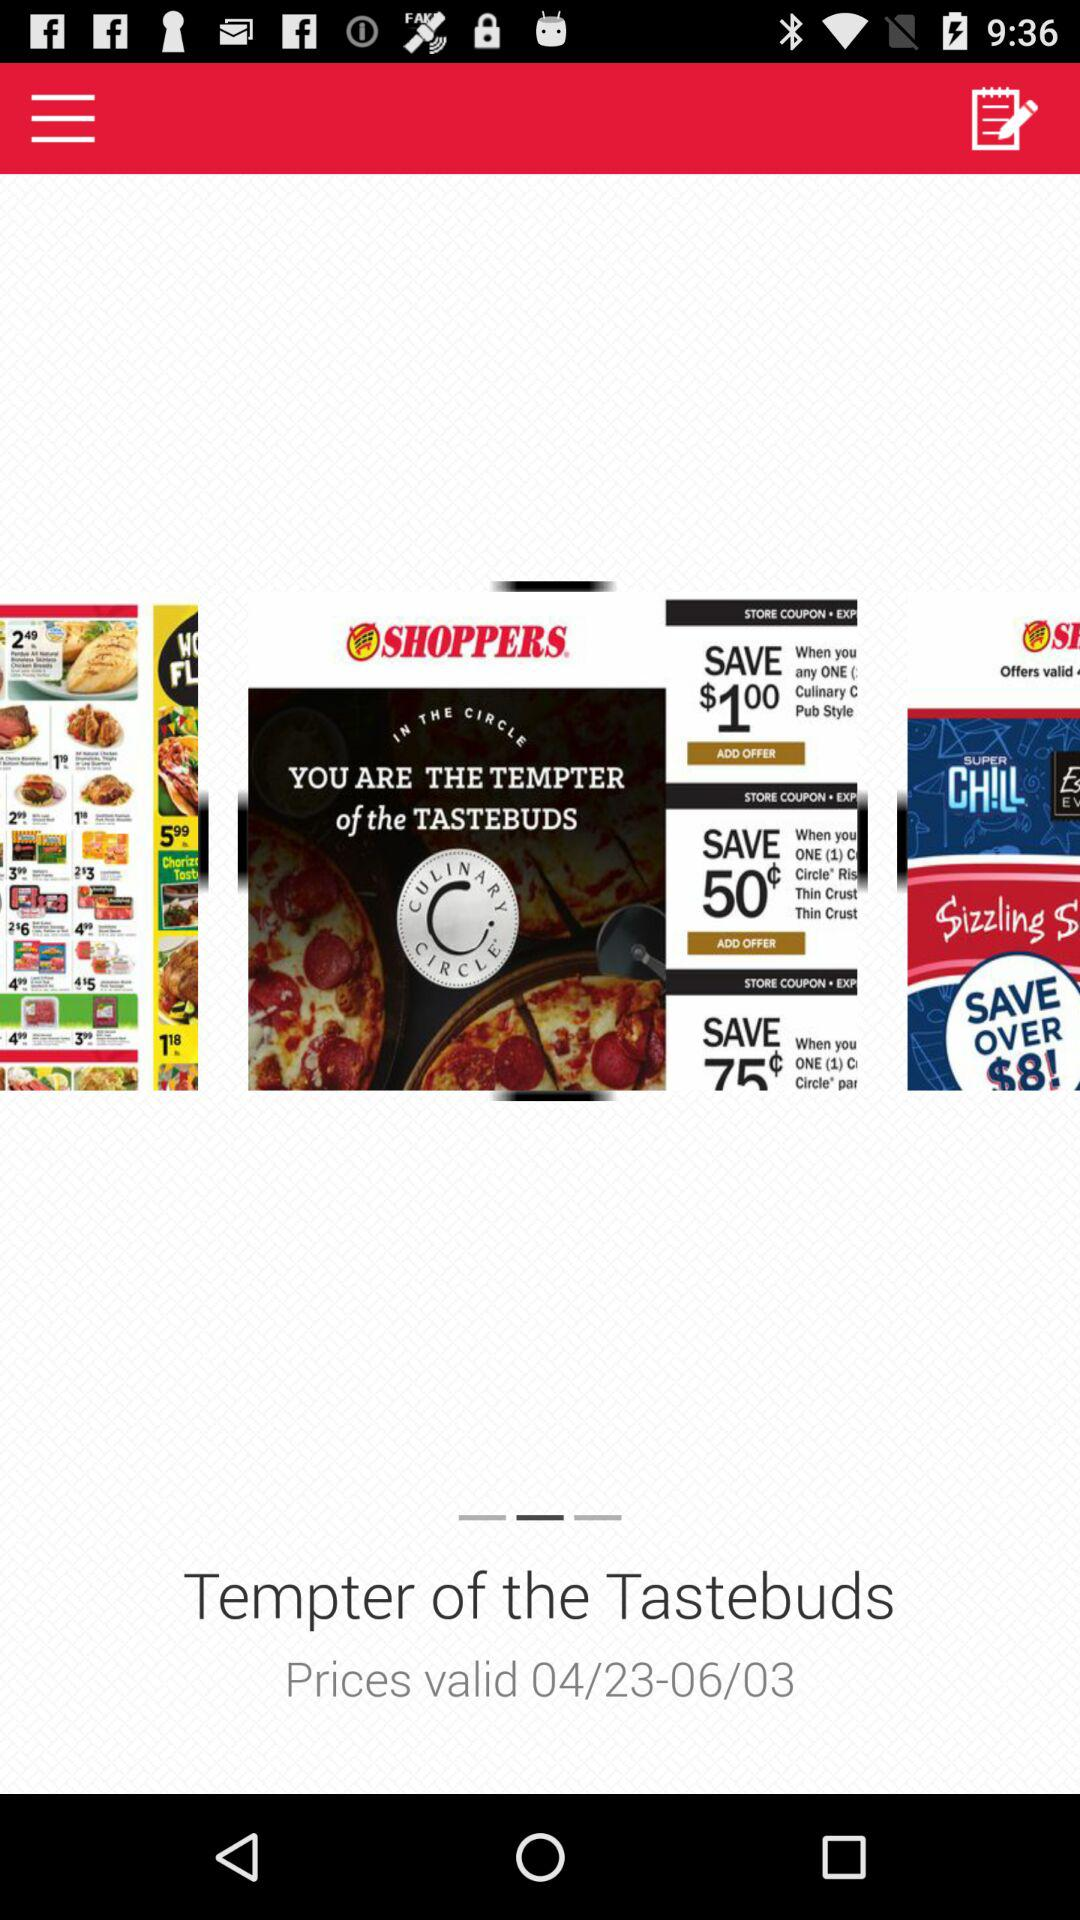How many flyers are there in total?
Answer the question using a single word or phrase. 3 